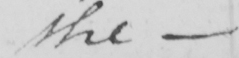Transcribe the text shown in this historical manuscript line. the 